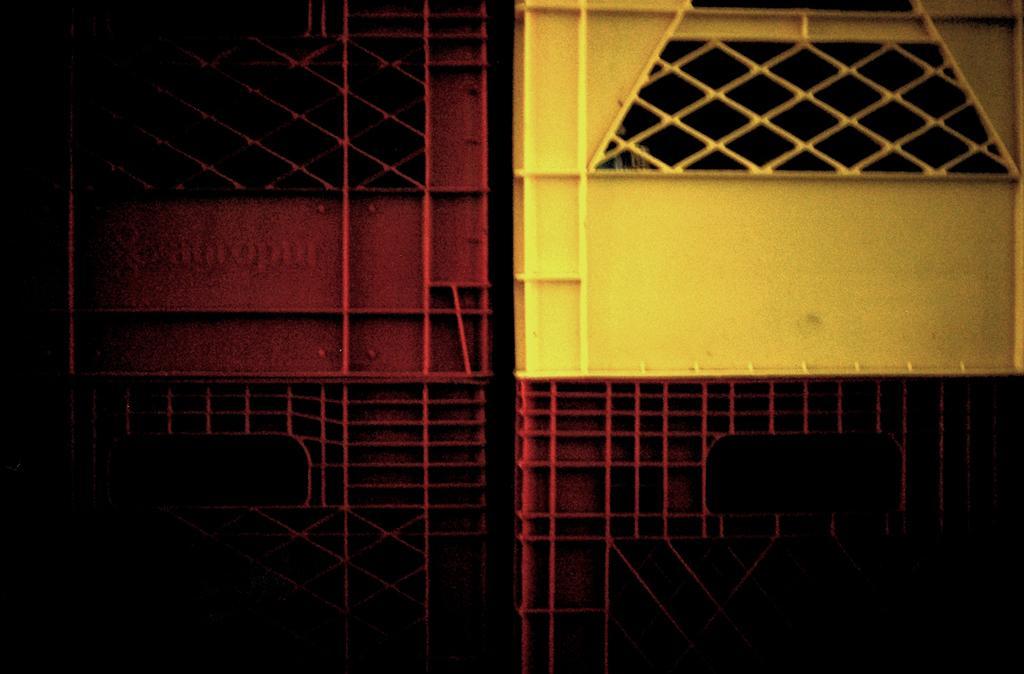In one or two sentences, can you explain what this image depicts? In this picture I can see there is a gate and it is in yellow and red color. The image at left is dark. 